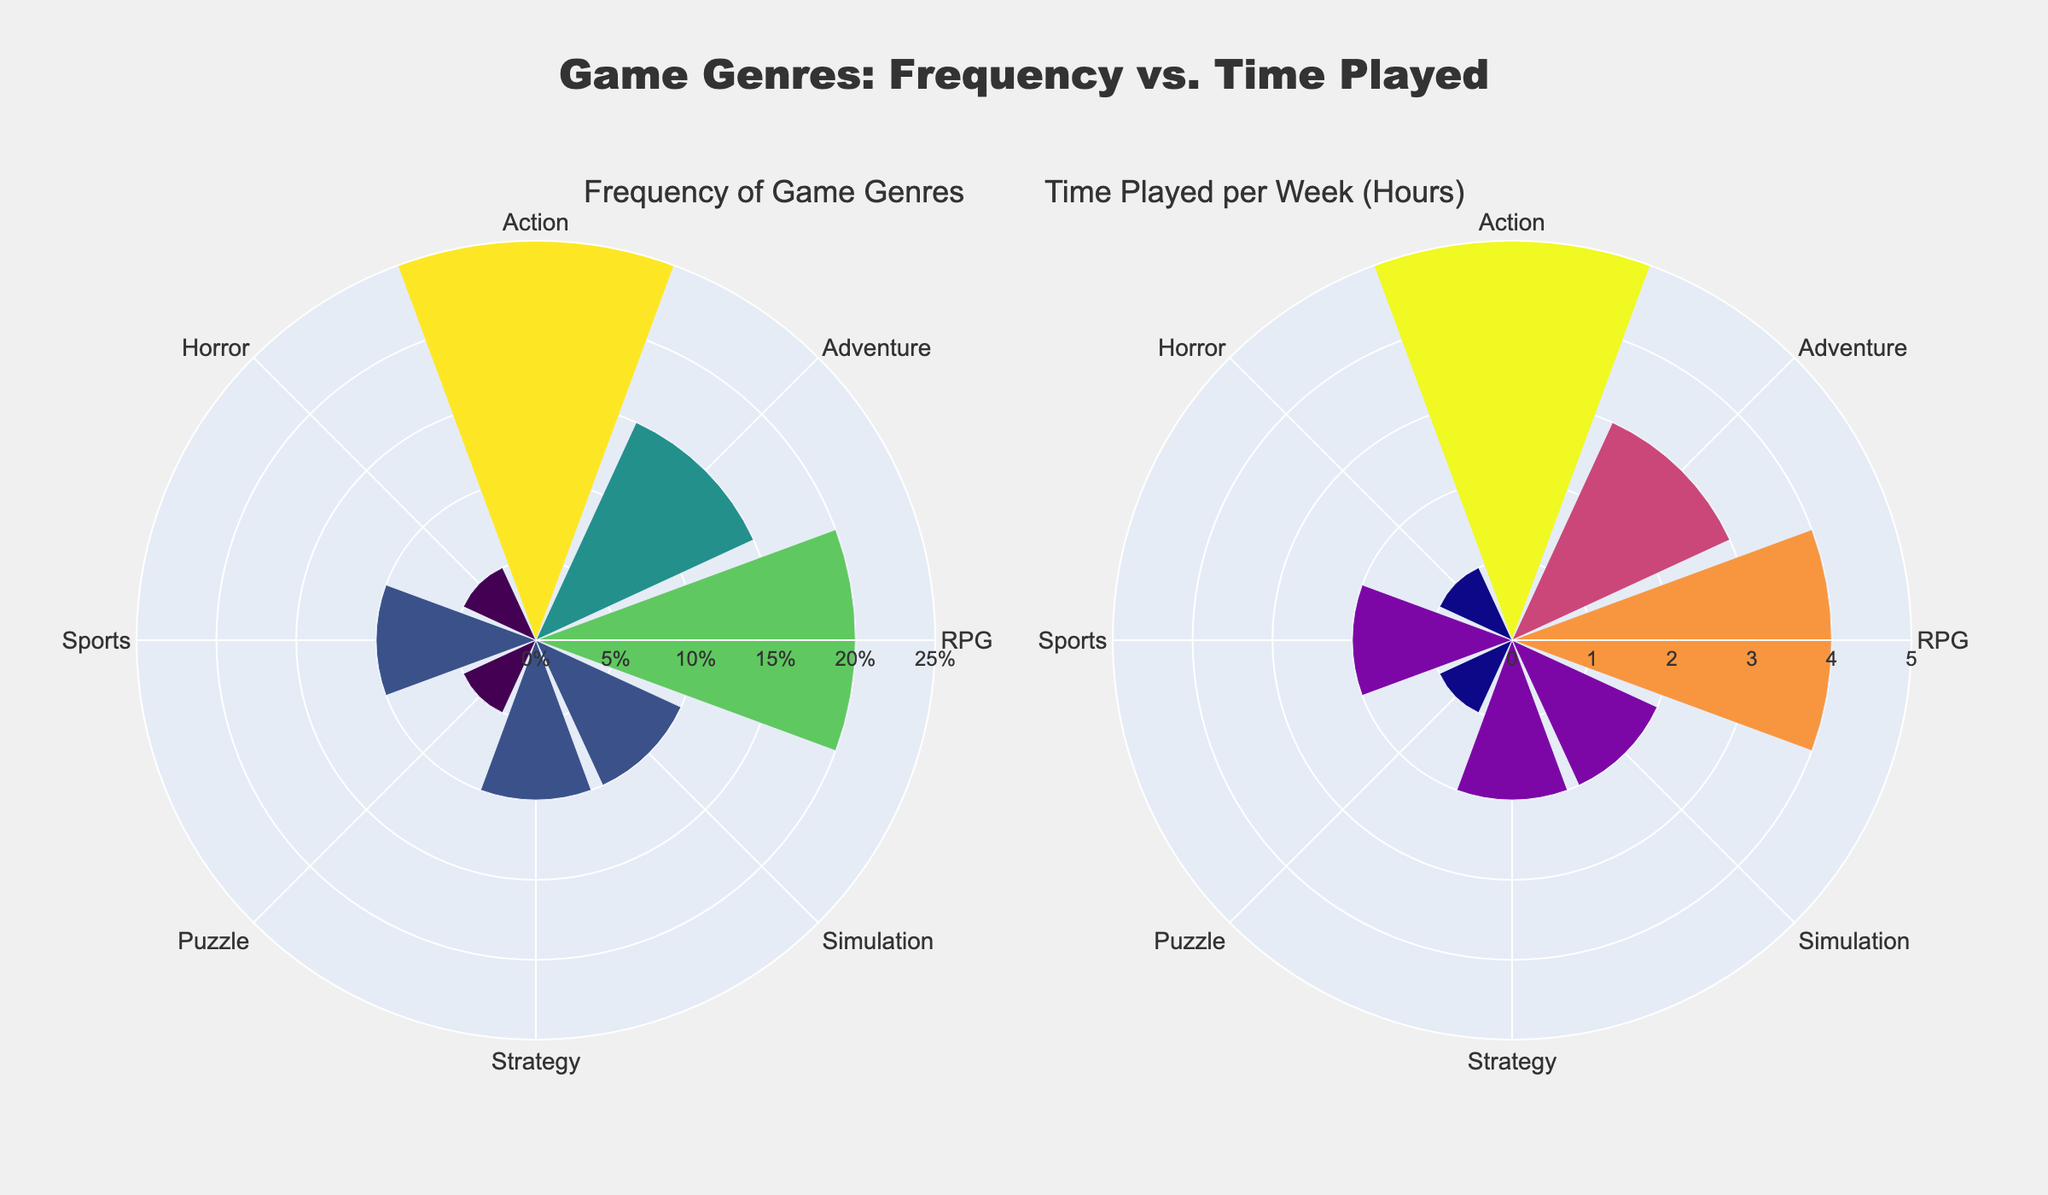What is the genre with the highest frequency of being played? The "Frequency of Game Genres" subplot on the left shows that Action has the longest bar, indicating the highest frequency.
Answer: Action Which genre is played for the most hours per week? The "Time Played per Week (Hours)" subplot on the right shows that Action has the longest bar, indicating it is played the most hours per week.
Answer: Action How does the frequency of playing RPG games compare to Adventure games? In the "Frequency of Game Genres" subplot, the bar for RPG is taller than the bar for Adventure, indicating a higher frequency.
Answer: RPG has a higher frequency than Adventure What is the combined weekly time spent playing Simulation and Strategy games? On the "Time Played per Week (Hours)" subplot, both Simulation and Strategy each show 2 hours per week. Adding these gives 2 + 2 = 4 hours.
Answer: 4 hours What percentage of the audience plays Puzzle games? The "Frequency of Game Genres" subplot shows a bar for Puzzle that corresponds to 5% frequency.
Answer: 5% Compare the playing time between Sports and Horror games. The "Time Played per Week (Hours)" subplot shows that both Sports and Horror have bars denoting 2 and 1 hours, respectively. Hence, Sports is played 1 hour more per week than Horror.
Answer: Sports is played 1 hour more Which genre has the lowest frequency of being played? The "Frequency of Game Genres" subplot shows that Puzzle and Horror both have short bars at the same lowest level of 5%.
Answer: Puzzle and Horror How much more frequently are RPG games played compared to Simulation games? The "Frequency of Game Genres" subplot shows that RPG games have a frequency of 20%, while Simulation games have 10%. The difference is 20% - 10% = 10%.
Answer: 10% more What is the total weekly playing time for genres with 5% frequency? On the "Time Played per Week (Hours)" subplot, Puzzle and Horror each show 1 hour per week. Adding these gives 1 + 1 = 2 hours.
Answer: 2 hours 